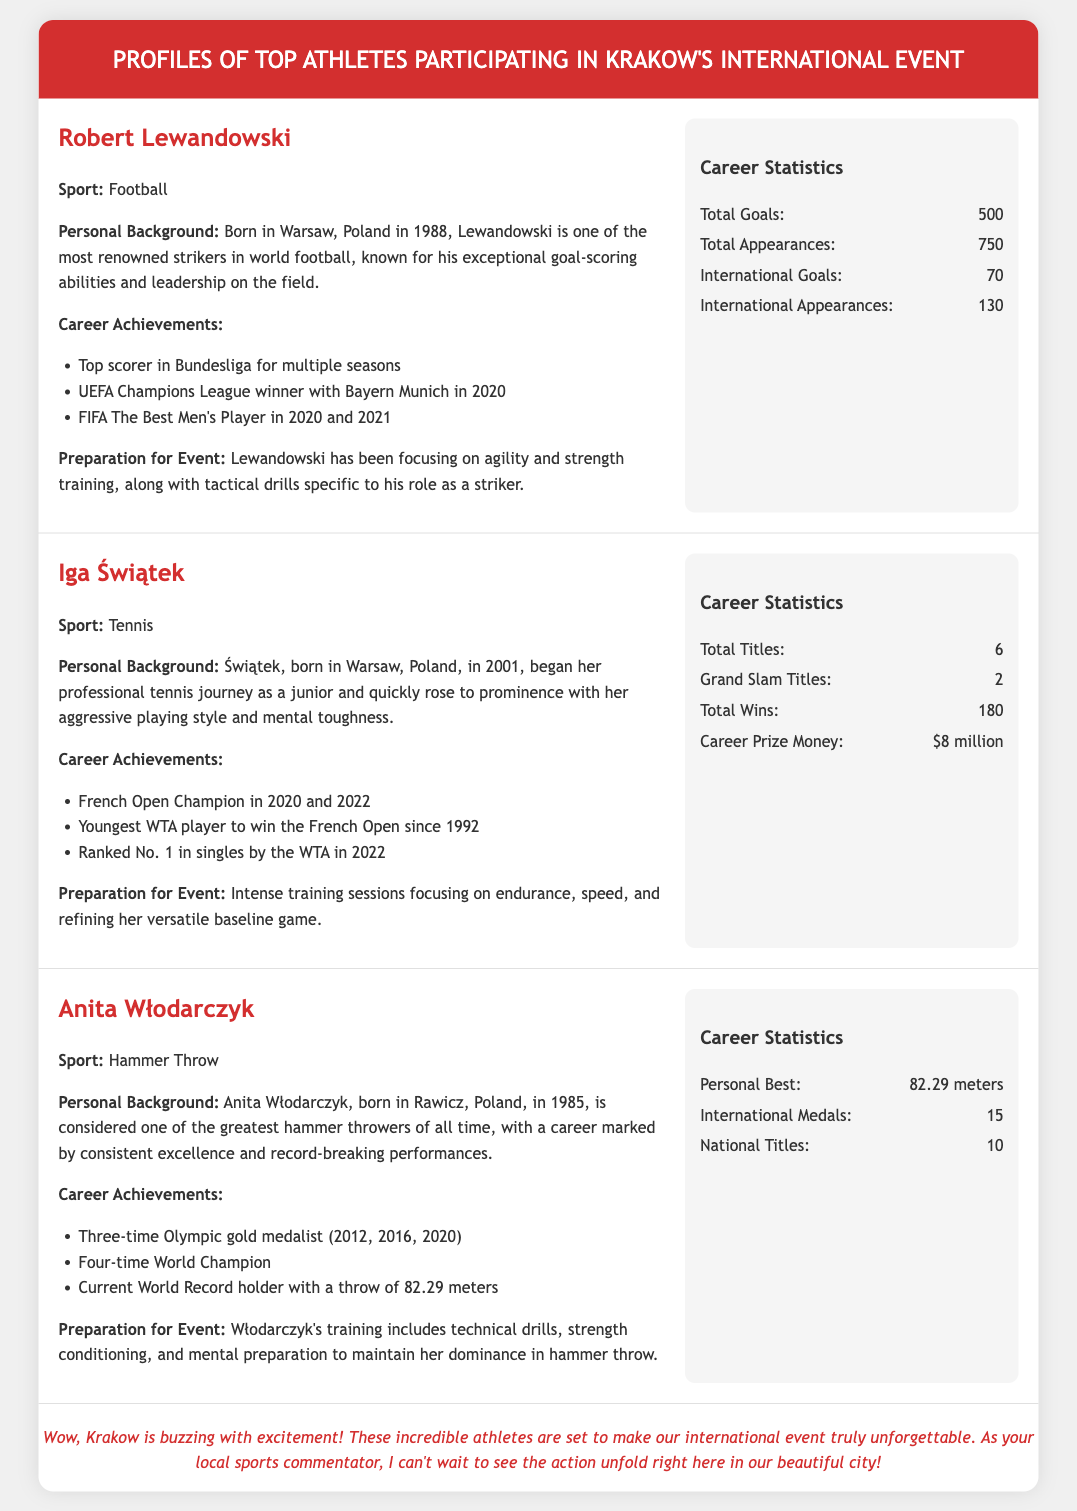What is Robert Lewandowski's sport? The document states that his sport is football.
Answer: Football How many Olympic gold medals has Anita Włodarczyk won? The document lists her as a three-time Olympic gold medalist.
Answer: 3 In what year did Iga Świątek win her first French Open? The document mentions that she won the French Open in 2020.
Answer: 2020 What is Robert Lewandowski's total goals scored? The document states that he has scored a total of 500 goals.
Answer: 500 How many Grand Slam titles does Iga Świątek have? The information in the document indicates that she has won 2 Grand Slam titles.
Answer: 2 What is Anita Włodarczyk's personal best throw distance? The document specifies that her personal best is 82.29 meters.
Answer: 82.29 meters Which city is hosting the international event? The document reveals that Krakow is the host city for the event.
Answer: Krakow What type of training is Robert Lewandowski focusing on? The document specifies that he is focusing on agility and strength training.
Answer: Agility and strength training What overall ranking did Iga Świątek achieve in 2022? The document states that she was ranked No. 1 in singles by the WTA in 2022.
Answer: No. 1 